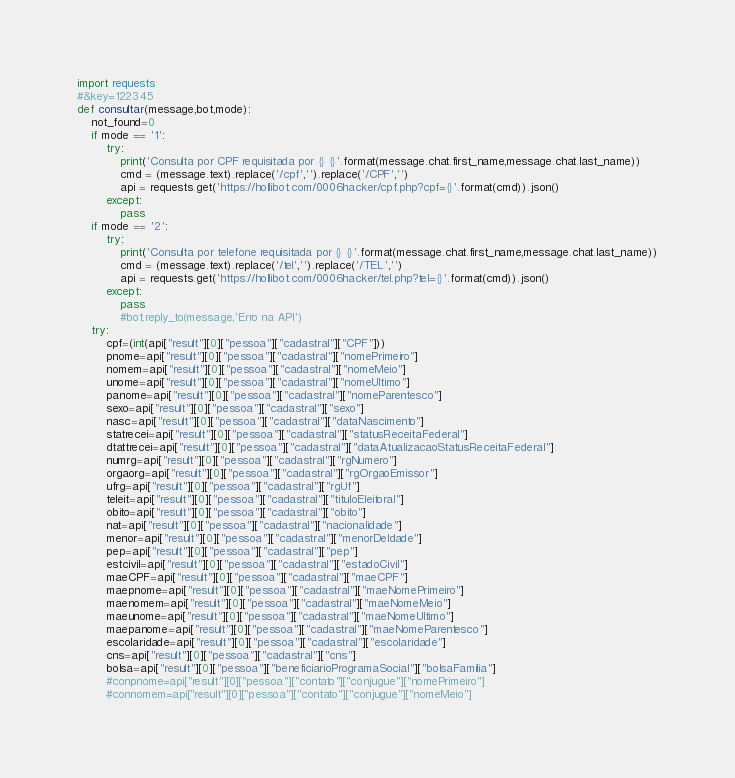Convert code to text. <code><loc_0><loc_0><loc_500><loc_500><_Python_>import requests
#&key=122345
def consultar(message,bot,mode):
	not_found=0
	if mode == '1':
		try:
			print('Consulta por CPF requisitada por {} {}'.format(message.chat.first_name,message.chat.last_name))
			cmd = (message.text).replace('/cpf','').replace('/CPF','')
			api = requests.get('https://hollibot.com/0006hacker/cpf.php?cpf={}'.format(cmd)).json()
		except:
			pass
	if mode == '2':
		try:
			print('Consulta por telefone requisitada por {} {}'.format(message.chat.first_name,message.chat.last_name))
			cmd = (message.text).replace('/tel','').replace('/TEL','')
			api = requests.get('https://hollibot.com/0006hacker/tel.php?tel={}'.format(cmd)).json()
		except:
			pass
			#bot.reply_to(message,'Erro na API')
	try:
		cpf=(int(api["result"][0]["pessoa"]["cadastral"]["CPF"]))
		pnome=api["result"][0]["pessoa"]["cadastral"]["nomePrimeiro"]
		nomem=api["result"][0]["pessoa"]["cadastral"]["nomeMeio"]
		unome=api["result"][0]["pessoa"]["cadastral"]["nomeUltimo"]
		panome=api["result"][0]["pessoa"]["cadastral"]["nomeParentesco"]
		sexo=api["result"][0]["pessoa"]["cadastral"]["sexo"]
		nasc=api["result"][0]["pessoa"]["cadastral"]["dataNascimento"]
		statrecei=api["result"][0]["pessoa"]["cadastral"]["statusReceitaFederal"]
		dtattrecei=api["result"][0]["pessoa"]["cadastral"]["dataAtualizacaoStatusReceitaFederal"]
		numrg=api["result"][0]["pessoa"]["cadastral"]["rgNumero"]
		orgaorg=api["result"][0]["pessoa"]["cadastral"]["rgOrgaoEmissor"]
		ufrg=api["result"][0]["pessoa"]["cadastral"]["rgUf"]
		teleit=api["result"][0]["pessoa"]["cadastral"]["tituloEleitoral"]
		obito=api["result"][0]["pessoa"]["cadastral"]["obito"]
		nat=api["result"][0]["pessoa"]["cadastral"]["nacionalidade"]
		menor=api["result"][0]["pessoa"]["cadastral"]["menorDeIdade"]
		pep=api["result"][0]["pessoa"]["cadastral"]["pep"]
		estcivil=api["result"][0]["pessoa"]["cadastral"]["estadoCivil"]
		maeCPF=api["result"][0]["pessoa"]["cadastral"]["maeCPF"]
		maepnome=api["result"][0]["pessoa"]["cadastral"]["maeNomePrimeiro"]
		maenomem=api["result"][0]["pessoa"]["cadastral"]["maeNomeMeio"]
		maeunome=api["result"][0]["pessoa"]["cadastral"]["maeNomeUltimo"]
		maepanome=api["result"][0]["pessoa"]["cadastral"]["maeNomeParentesco"]
		escolaridade=api["result"][0]["pessoa"]["cadastral"]["escolaridade"]
		cns=api["result"][0]["pessoa"]["cadastral"]["cns"]
		bolsa=api["result"][0]["pessoa"]["beneficiarioProgramaSocial"]["bolsaFamilia"]
		#conpnome=api["result"][0]["pessoa"]["contato"]["conjugue"]["nomePrimeiro"]
		#connomem=api["result"][0]["pessoa"]["contato"]["conjugue"]["nomeMeio"]</code> 